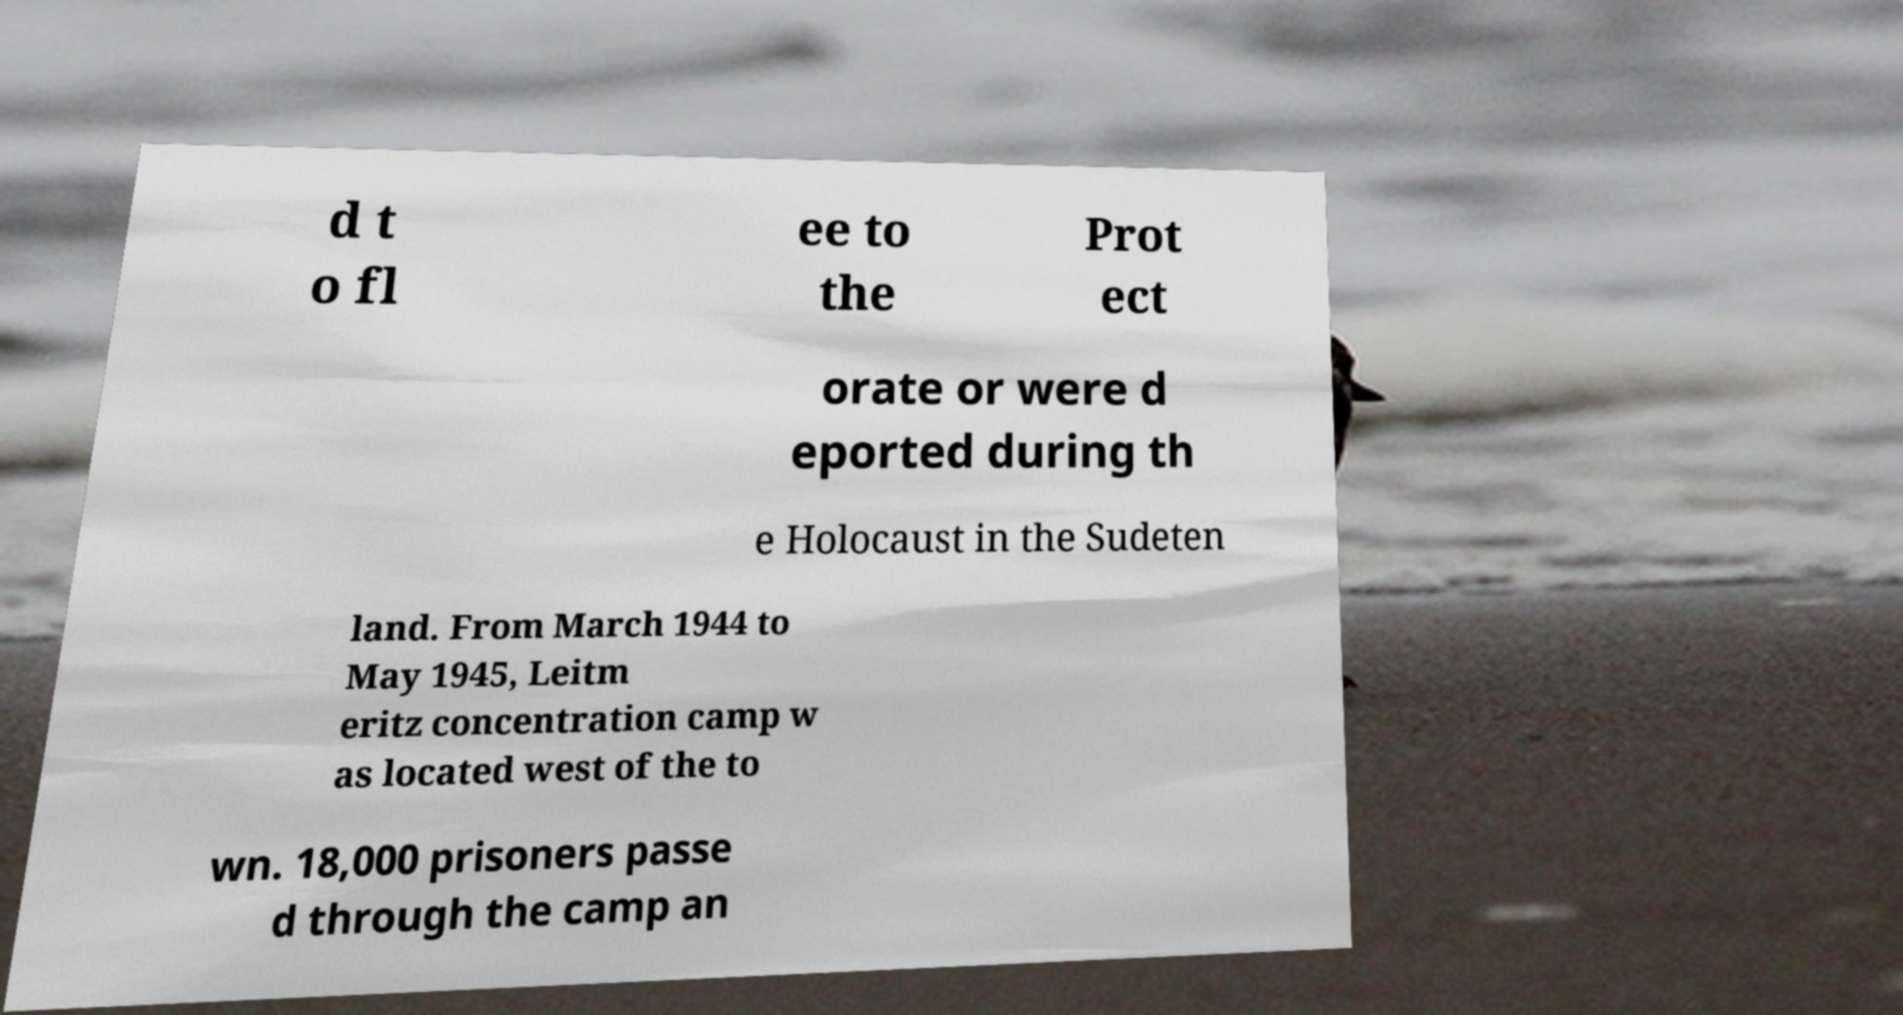What messages or text are displayed in this image? I need them in a readable, typed format. d t o fl ee to the Prot ect orate or were d eported during th e Holocaust in the Sudeten land. From March 1944 to May 1945, Leitm eritz concentration camp w as located west of the to wn. 18,000 prisoners passe d through the camp an 